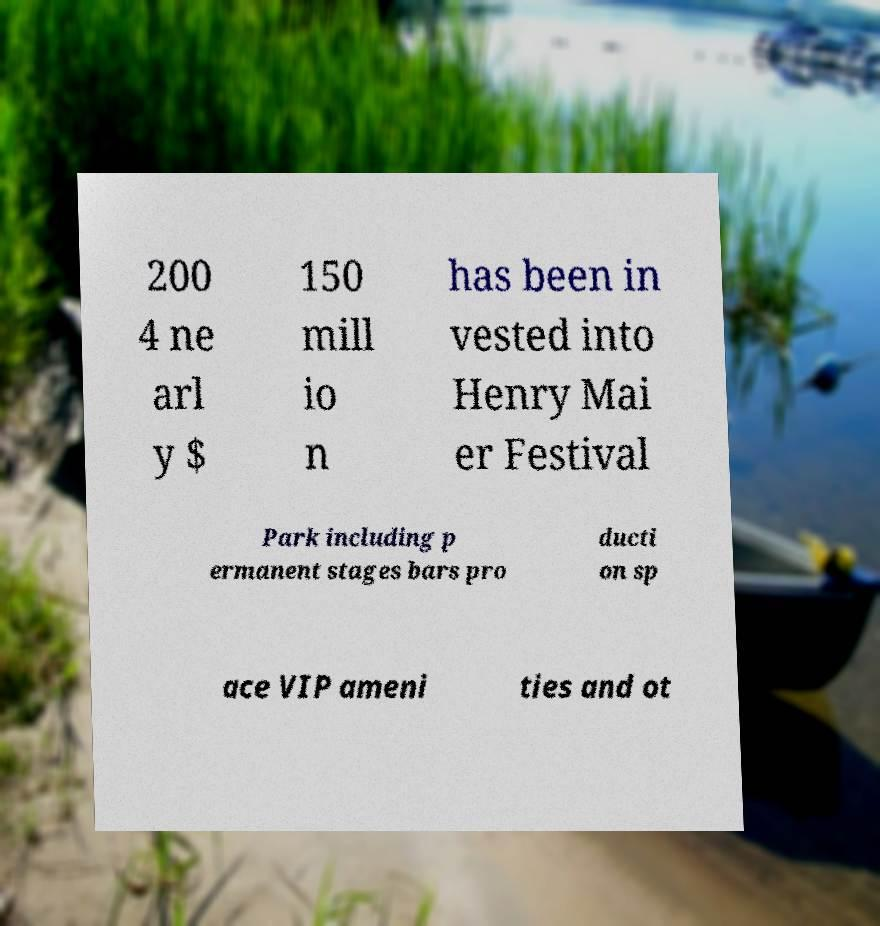Please read and relay the text visible in this image. What does it say? 200 4 ne arl y $ 150 mill io n has been in vested into Henry Mai er Festival Park including p ermanent stages bars pro ducti on sp ace VIP ameni ties and ot 